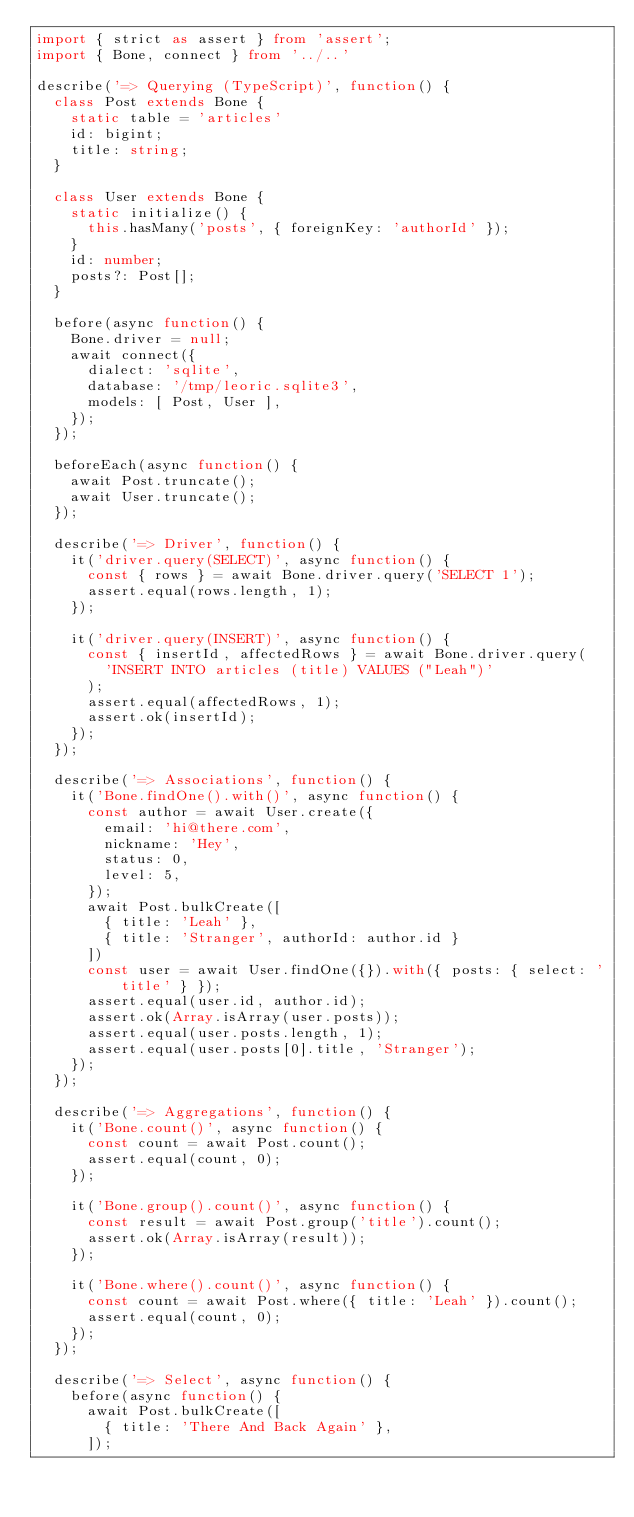<code> <loc_0><loc_0><loc_500><loc_500><_TypeScript_>import { strict as assert } from 'assert';
import { Bone, connect } from '../..'

describe('=> Querying (TypeScript)', function() {
  class Post extends Bone {
    static table = 'articles'
    id: bigint;
    title: string;
  }

  class User extends Bone {
    static initialize() {
      this.hasMany('posts', { foreignKey: 'authorId' });
    }
    id: number;
    posts?: Post[];
  }

  before(async function() {
    Bone.driver = null;
    await connect({
      dialect: 'sqlite',
      database: '/tmp/leoric.sqlite3',
      models: [ Post, User ],
    });
  });

  beforeEach(async function() {
    await Post.truncate();
    await User.truncate();
  });

  describe('=> Driver', function() {
    it('driver.query(SELECT)', async function() {
      const { rows } = await Bone.driver.query('SELECT 1');
      assert.equal(rows.length, 1);
    });

    it('driver.query(INSERT)', async function() {
      const { insertId, affectedRows } = await Bone.driver.query(
        'INSERT INTO articles (title) VALUES ("Leah")'
      );
      assert.equal(affectedRows, 1);
      assert.ok(insertId);
    });
  });

  describe('=> Associations', function() {
    it('Bone.findOne().with()', async function() {
      const author = await User.create({
        email: 'hi@there.com',
        nickname: 'Hey',
        status: 0,
        level: 5,
      });
      await Post.bulkCreate([
        { title: 'Leah' },
        { title: 'Stranger', authorId: author.id }
      ])
      const user = await User.findOne({}).with({ posts: { select: 'title' } });
      assert.equal(user.id, author.id);
      assert.ok(Array.isArray(user.posts));
      assert.equal(user.posts.length, 1);
      assert.equal(user.posts[0].title, 'Stranger');
    });
  });

  describe('=> Aggregations', function() {
    it('Bone.count()', async function() {
      const count = await Post.count();
      assert.equal(count, 0);
    });

    it('Bone.group().count()', async function() {
      const result = await Post.group('title').count();
      assert.ok(Array.isArray(result));
    });

    it('Bone.where().count()', async function() {
      const count = await Post.where({ title: 'Leah' }).count();
      assert.equal(count, 0);
    });
  });

  describe('=> Select', async function() {
    before(async function() {
      await Post.bulkCreate([
        { title: 'There And Back Again' },
      ]);</code> 